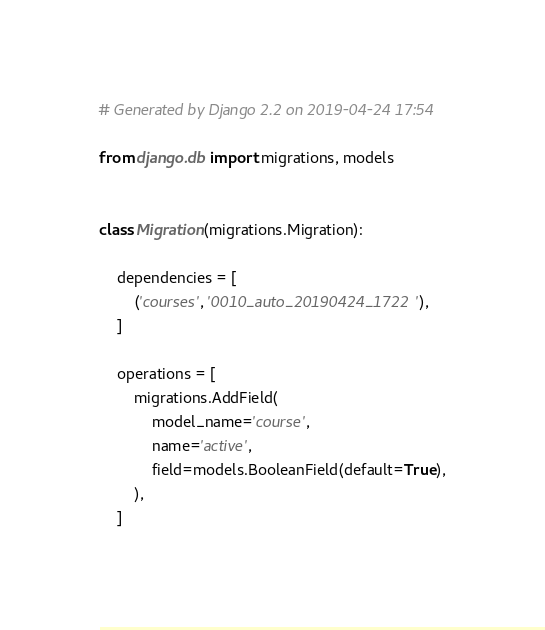Convert code to text. <code><loc_0><loc_0><loc_500><loc_500><_Python_># Generated by Django 2.2 on 2019-04-24 17:54

from django.db import migrations, models


class Migration(migrations.Migration):

    dependencies = [
        ('courses', '0010_auto_20190424_1722'),
    ]

    operations = [
        migrations.AddField(
            model_name='course',
            name='active',
            field=models.BooleanField(default=True),
        ),
    ]
</code> 